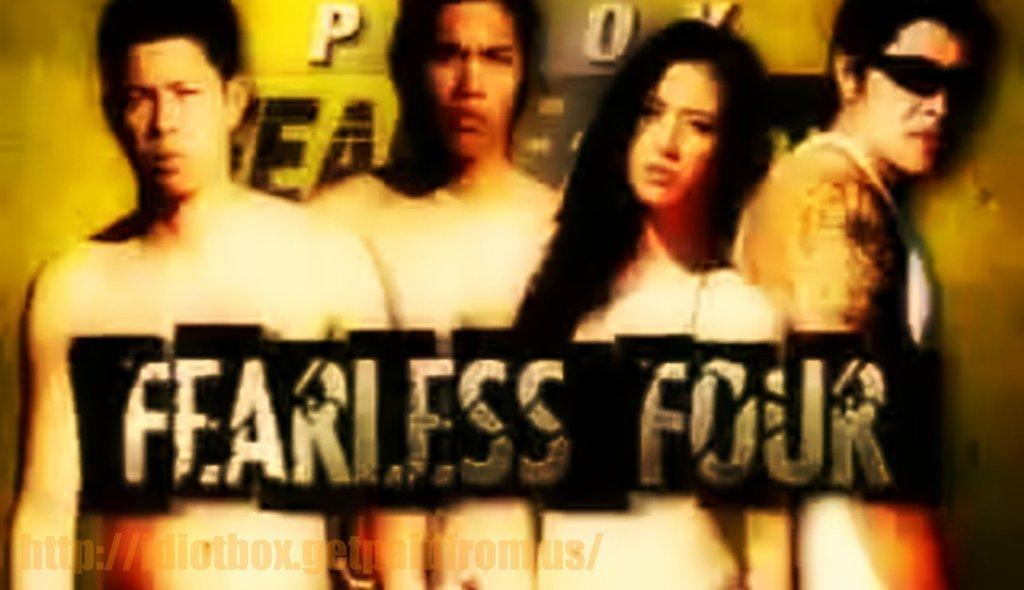What is present in the image? There is a poster in the image. What can be seen on the poster? The poster contains three men and a woman. Can you describe any specific details about one of the men? One of the men is wearing goggles. Is there any text on the poster? Yes, there is text visible on the poster. What type of skirt is the woman wearing in the image? There is no skirt visible in the image, as the woman is not wearing one. Can you describe the coil that is present in the image? There is no coil present in the image. 